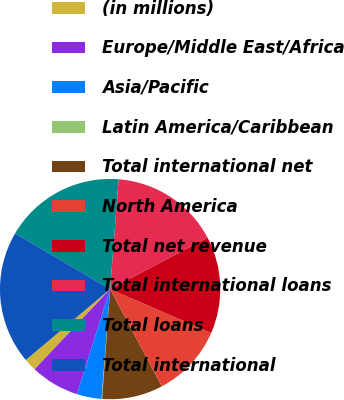Convert chart to OTSL. <chart><loc_0><loc_0><loc_500><loc_500><pie_chart><fcel>(in millions)<fcel>Europe/Middle East/Africa<fcel>Asia/Pacific<fcel>Latin America/Caribbean<fcel>Total international net<fcel>North America<fcel>Total net revenue<fcel>Total international loans<fcel>Total loans<fcel>Total international<nl><fcel>1.85%<fcel>7.16%<fcel>3.62%<fcel>0.08%<fcel>8.94%<fcel>10.71%<fcel>14.25%<fcel>16.03%<fcel>17.8%<fcel>19.57%<nl></chart> 